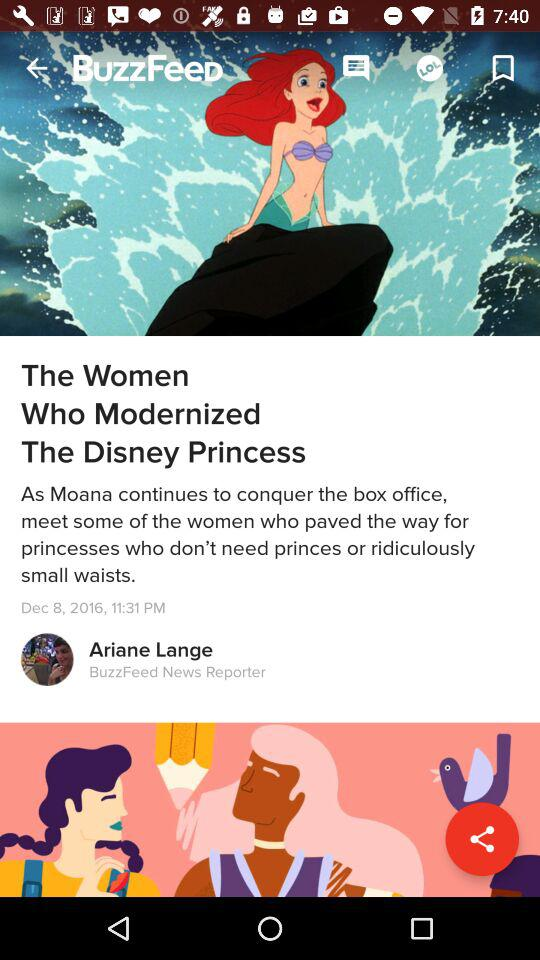When was the article published? The article was published on December 8, 2016 at 11:31 PM. 